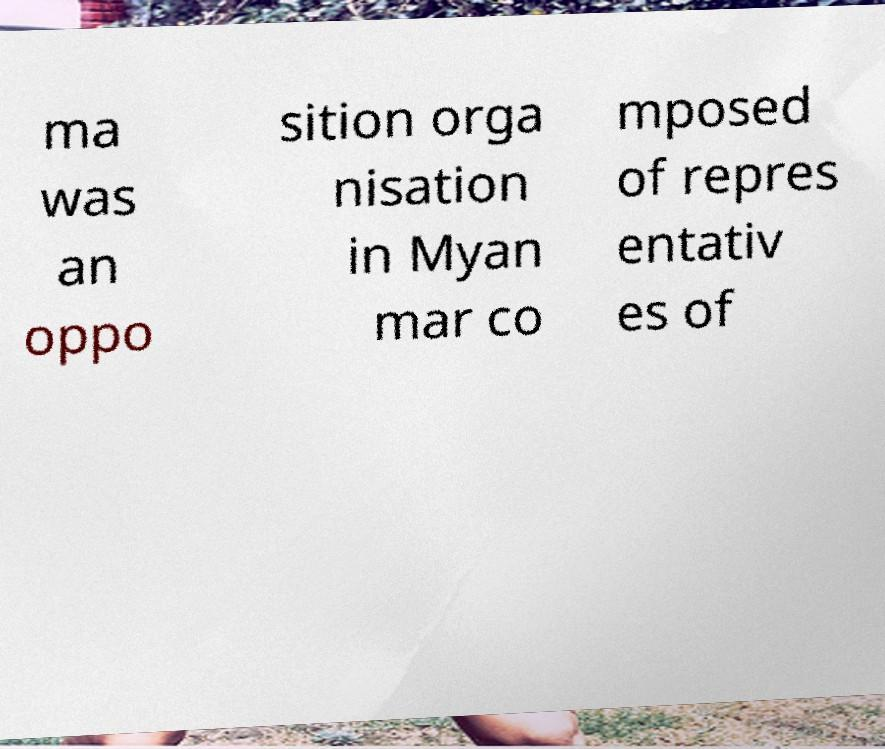Please read and relay the text visible in this image. What does it say? ma was an oppo sition orga nisation in Myan mar co mposed of repres entativ es of 